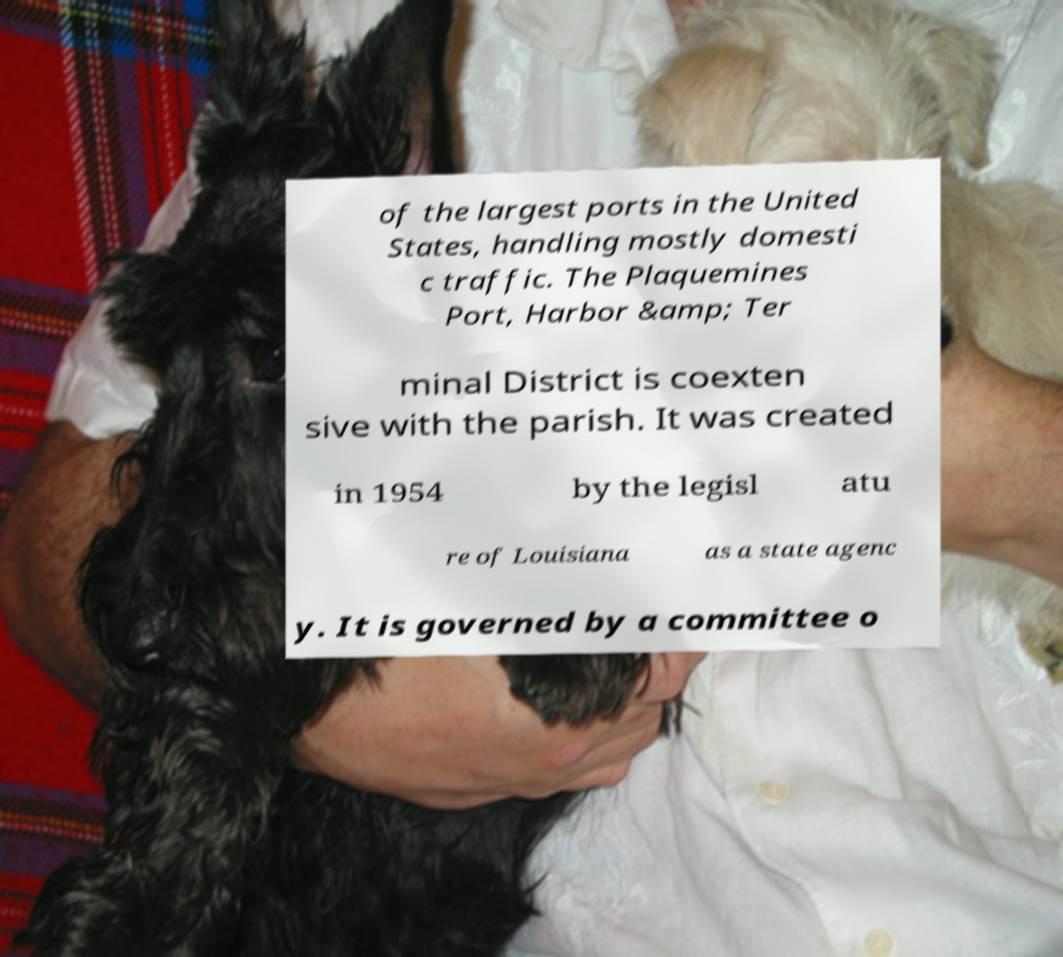Can you accurately transcribe the text from the provided image for me? of the largest ports in the United States, handling mostly domesti c traffic. The Plaquemines Port, Harbor &amp; Ter minal District is coexten sive with the parish. It was created in 1954 by the legisl atu re of Louisiana as a state agenc y. It is governed by a committee o 